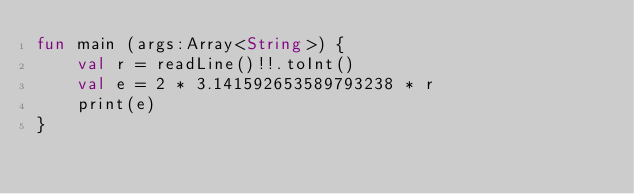<code> <loc_0><loc_0><loc_500><loc_500><_Kotlin_>fun main (args:Array<String>) {
    val r = readLine()!!.toInt()
    val e = 2 * 3.141592653589793238 * r
    print(e)
}</code> 